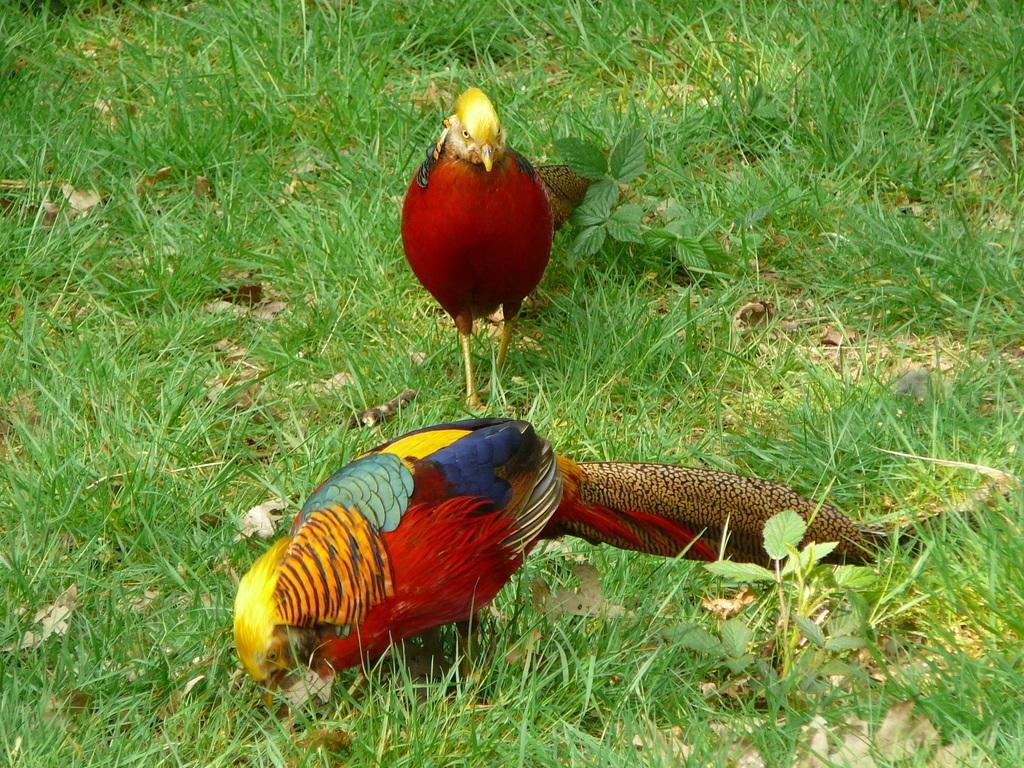What type of animals can be seen in the image? There are birds in the image. Where are the birds located in the image? The birds are standing on the ground in the image. What type of vegetation is present in the image? Grass is present in the image. What else can be seen on the ground in the image? Shredded leaves are visible in the image. Are the birds driving a car in the image? No, the birds are not driving a car in the image; they are standing on the ground. What type of coal can be seen in the image? There is no coal present in the image. 